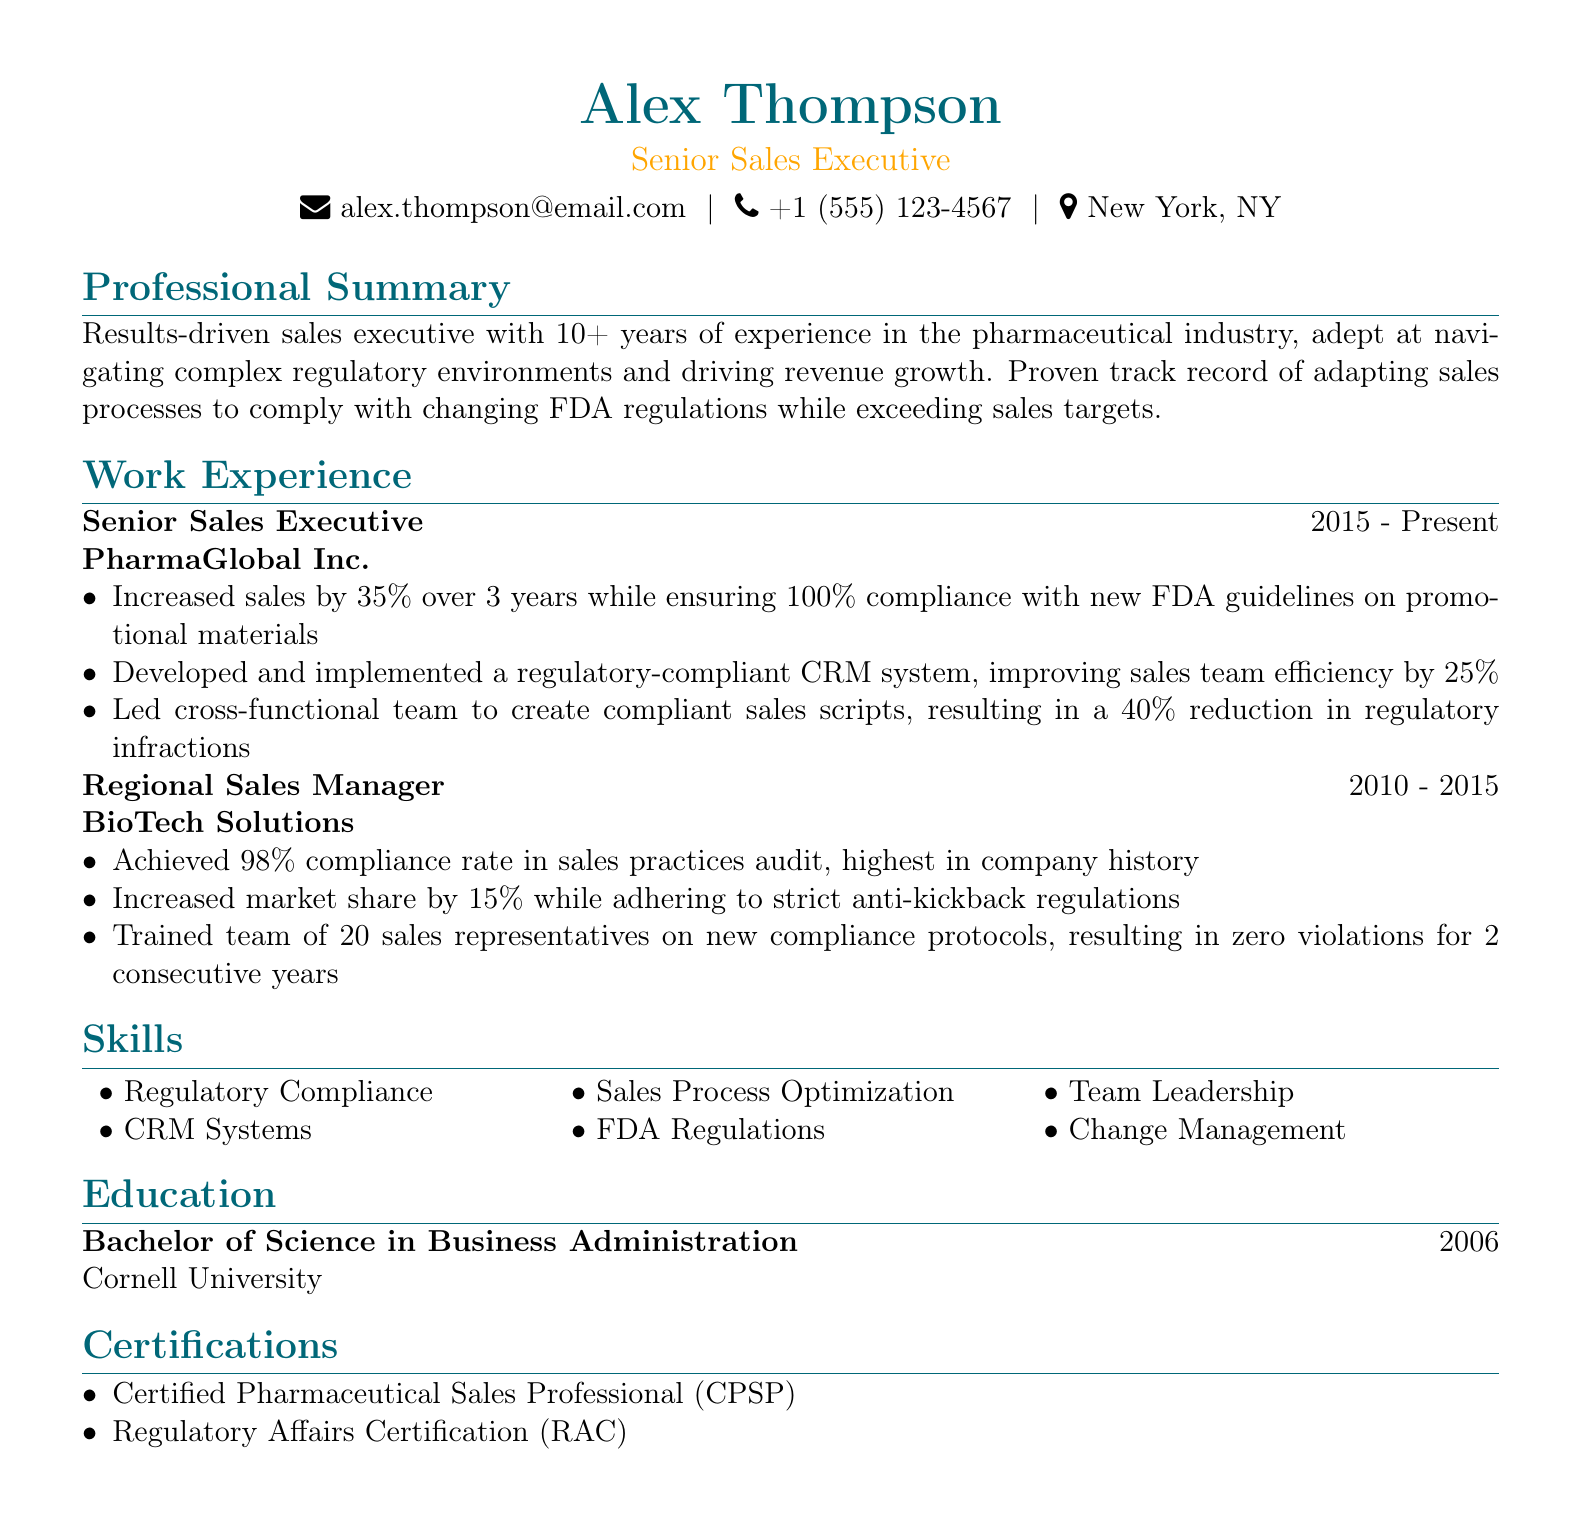what is the name of the individual in the CV? The name of the individual is clearly stated at the top of the document.
Answer: Alex Thompson what is the title listed below the name? The title is found immediately next to the name in the document.
Answer: Senior Sales Executive what is the duration of the position held at PharmaGlobal Inc.? The duration is mentioned under the work experience section for the specific position.
Answer: 2015 - Present how much did sales increase during the tenure at PharmaGlobal Inc.? This information is specified in the achievements of the work experience section.
Answer: 35% what compliance rate was achieved during the sales practices audit at BioTech Solutions? This statistic is provided in the achievements for the Regional Sales Manager position.
Answer: 98% which university did Alex attend for their degree? The education section states the institution where the degree was obtained.
Answer: Cornell University how many sales representatives were trained on new compliance protocols? The information is contained in the achievements for the Regional Sales Manager position.
Answer: 20 what are the two certifications listed in the CV? The certifications section mentions the professional qualifications obtained.
Answer: Certified Pharmaceutical Sales Professional (CPSP), Regulatory Affairs Certification (RAC) what improvement in efficiency was achieved with the new CRM system? This detail is part of the achievements under the Senior Sales Executive role.
Answer: 25% 